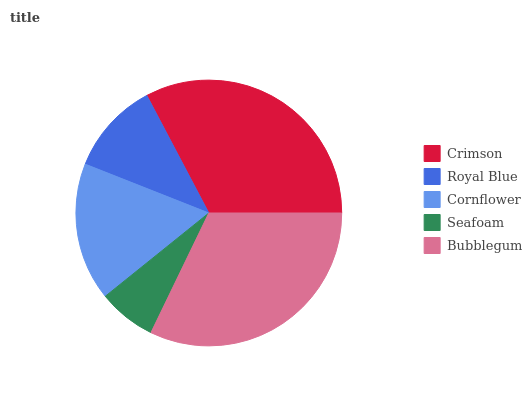Is Seafoam the minimum?
Answer yes or no. Yes. Is Crimson the maximum?
Answer yes or no. Yes. Is Royal Blue the minimum?
Answer yes or no. No. Is Royal Blue the maximum?
Answer yes or no. No. Is Crimson greater than Royal Blue?
Answer yes or no. Yes. Is Royal Blue less than Crimson?
Answer yes or no. Yes. Is Royal Blue greater than Crimson?
Answer yes or no. No. Is Crimson less than Royal Blue?
Answer yes or no. No. Is Cornflower the high median?
Answer yes or no. Yes. Is Cornflower the low median?
Answer yes or no. Yes. Is Crimson the high median?
Answer yes or no. No. Is Seafoam the low median?
Answer yes or no. No. 